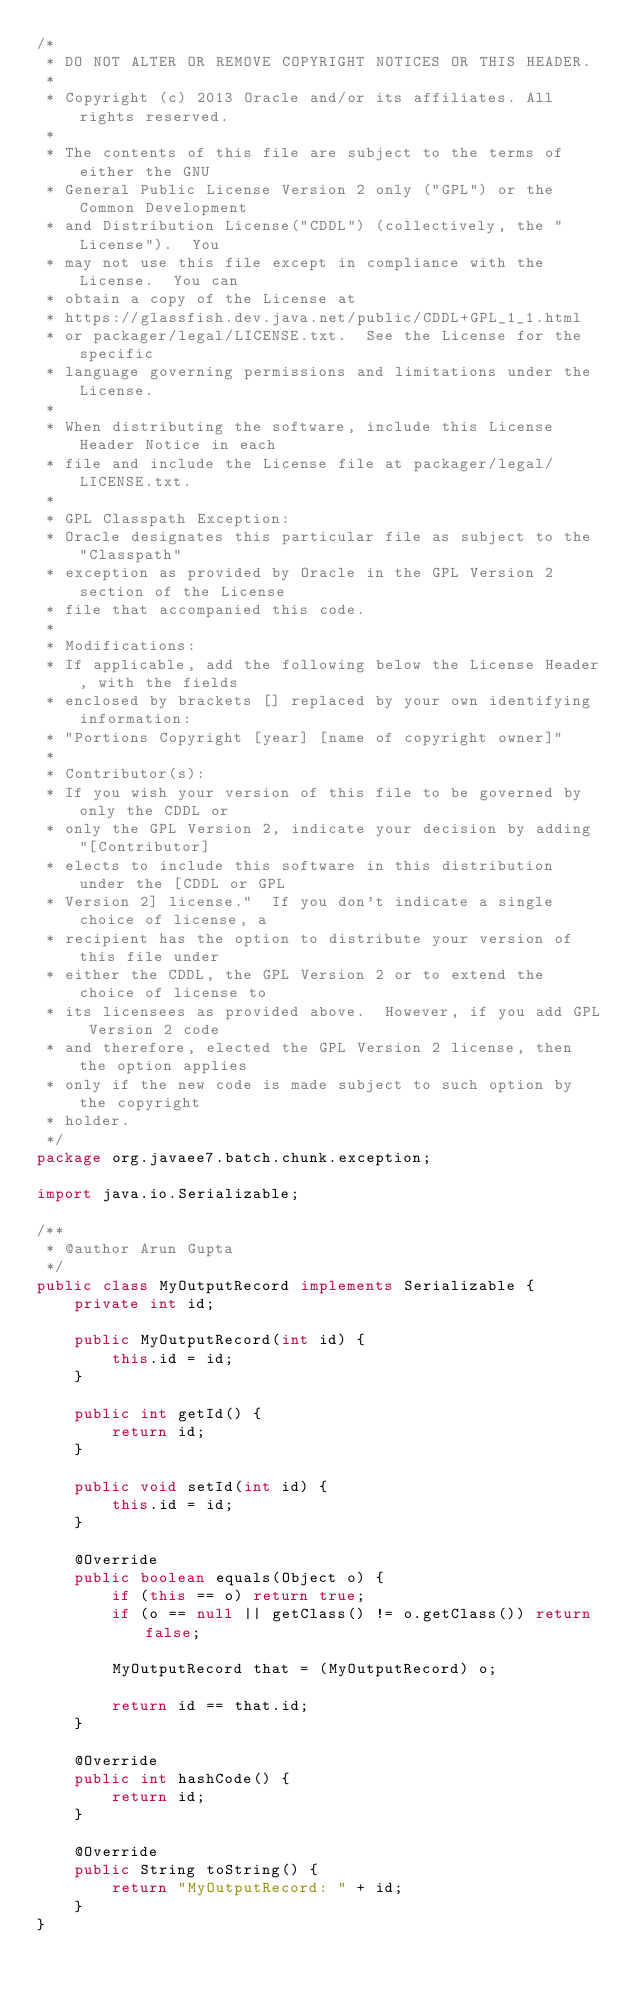Convert code to text. <code><loc_0><loc_0><loc_500><loc_500><_Java_>/*
 * DO NOT ALTER OR REMOVE COPYRIGHT NOTICES OR THIS HEADER.
 *
 * Copyright (c) 2013 Oracle and/or its affiliates. All rights reserved.
 *
 * The contents of this file are subject to the terms of either the GNU
 * General Public License Version 2 only ("GPL") or the Common Development
 * and Distribution License("CDDL") (collectively, the "License").  You
 * may not use this file except in compliance with the License.  You can
 * obtain a copy of the License at
 * https://glassfish.dev.java.net/public/CDDL+GPL_1_1.html
 * or packager/legal/LICENSE.txt.  See the License for the specific
 * language governing permissions and limitations under the License.
 *
 * When distributing the software, include this License Header Notice in each
 * file and include the License file at packager/legal/LICENSE.txt.
 *
 * GPL Classpath Exception:
 * Oracle designates this particular file as subject to the "Classpath"
 * exception as provided by Oracle in the GPL Version 2 section of the License
 * file that accompanied this code.
 *
 * Modifications:
 * If applicable, add the following below the License Header, with the fields
 * enclosed by brackets [] replaced by your own identifying information:
 * "Portions Copyright [year] [name of copyright owner]"
 *
 * Contributor(s):
 * If you wish your version of this file to be governed by only the CDDL or
 * only the GPL Version 2, indicate your decision by adding "[Contributor]
 * elects to include this software in this distribution under the [CDDL or GPL
 * Version 2] license."  If you don't indicate a single choice of license, a
 * recipient has the option to distribute your version of this file under
 * either the CDDL, the GPL Version 2 or to extend the choice of license to
 * its licensees as provided above.  However, if you add GPL Version 2 code
 * and therefore, elected the GPL Version 2 license, then the option applies
 * only if the new code is made subject to such option by the copyright
 * holder.
 */
package org.javaee7.batch.chunk.exception;

import java.io.Serializable;

/**
 * @author Arun Gupta
 */
public class MyOutputRecord implements Serializable {
    private int id;

    public MyOutputRecord(int id) {
        this.id = id;
    }

    public int getId() {
        return id;
    }

    public void setId(int id) {
        this.id = id;
    }

    @Override
    public boolean equals(Object o) {
        if (this == o) return true;
        if (o == null || getClass() != o.getClass()) return false;

        MyOutputRecord that = (MyOutputRecord) o;

        return id == that.id;
    }

    @Override
    public int hashCode() {
        return id;
    }

    @Override
    public String toString() {
        return "MyOutputRecord: " + id;
    }
}
</code> 